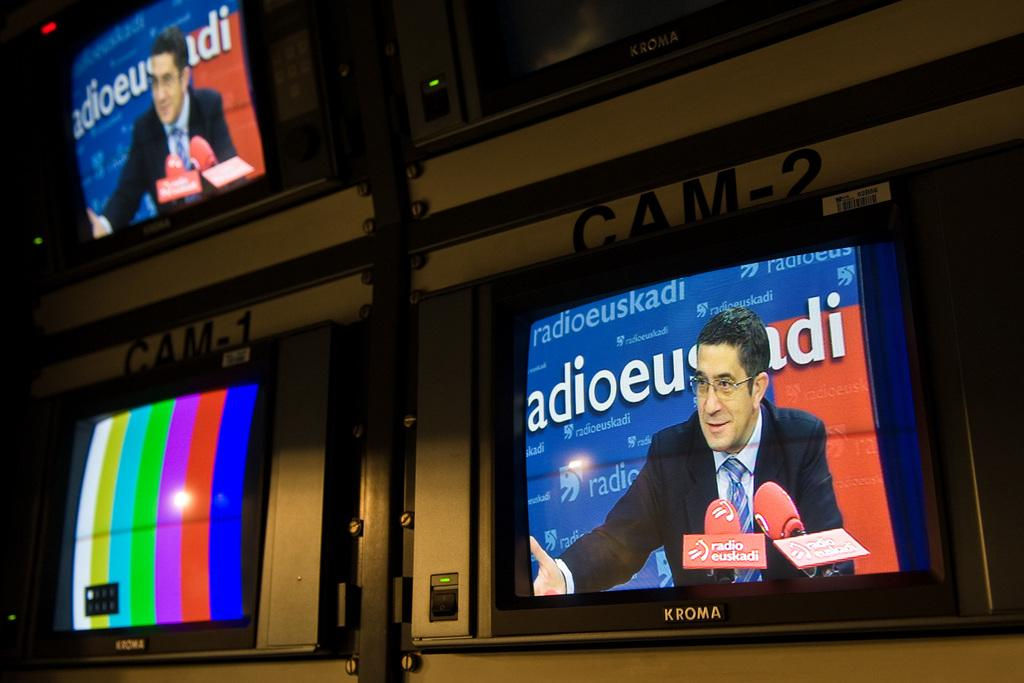Provide a one-sentence caption for the provided image. TV Monitors have the words Cam-1 and Cam-2 above them. 